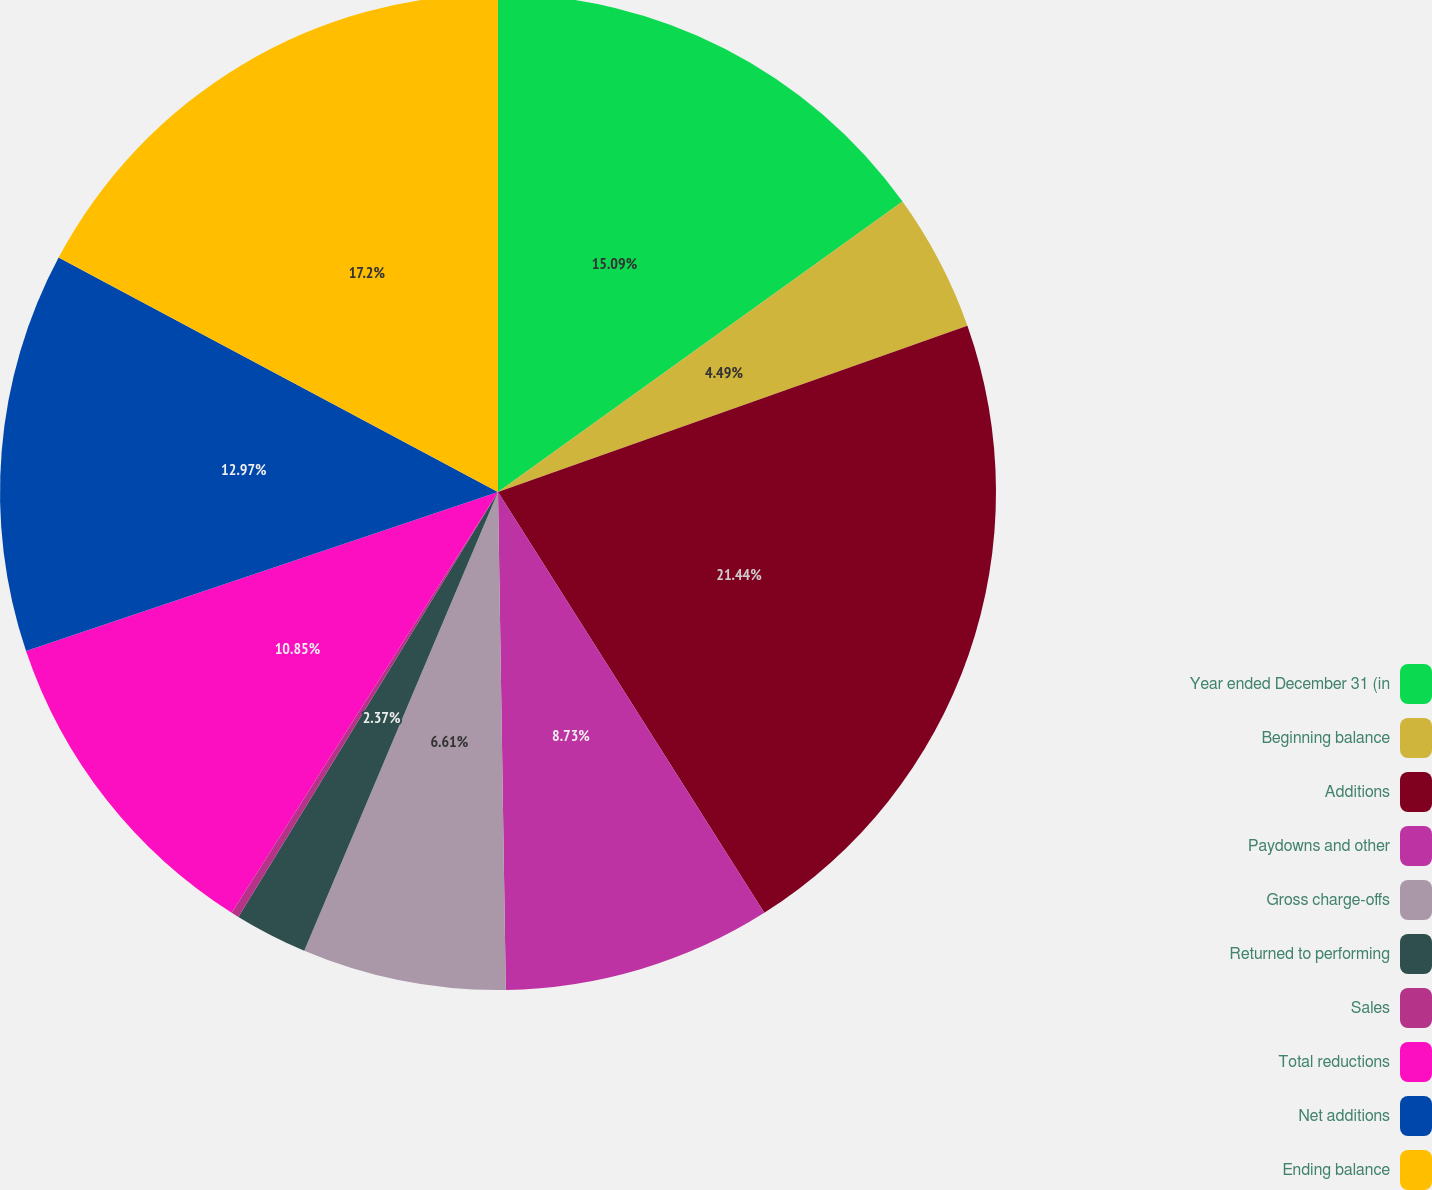Convert chart to OTSL. <chart><loc_0><loc_0><loc_500><loc_500><pie_chart><fcel>Year ended December 31 (in<fcel>Beginning balance<fcel>Additions<fcel>Paydowns and other<fcel>Gross charge-offs<fcel>Returned to performing<fcel>Sales<fcel>Total reductions<fcel>Net additions<fcel>Ending balance<nl><fcel>15.09%<fcel>4.49%<fcel>21.44%<fcel>8.73%<fcel>6.61%<fcel>2.37%<fcel>0.25%<fcel>10.85%<fcel>12.97%<fcel>17.2%<nl></chart> 